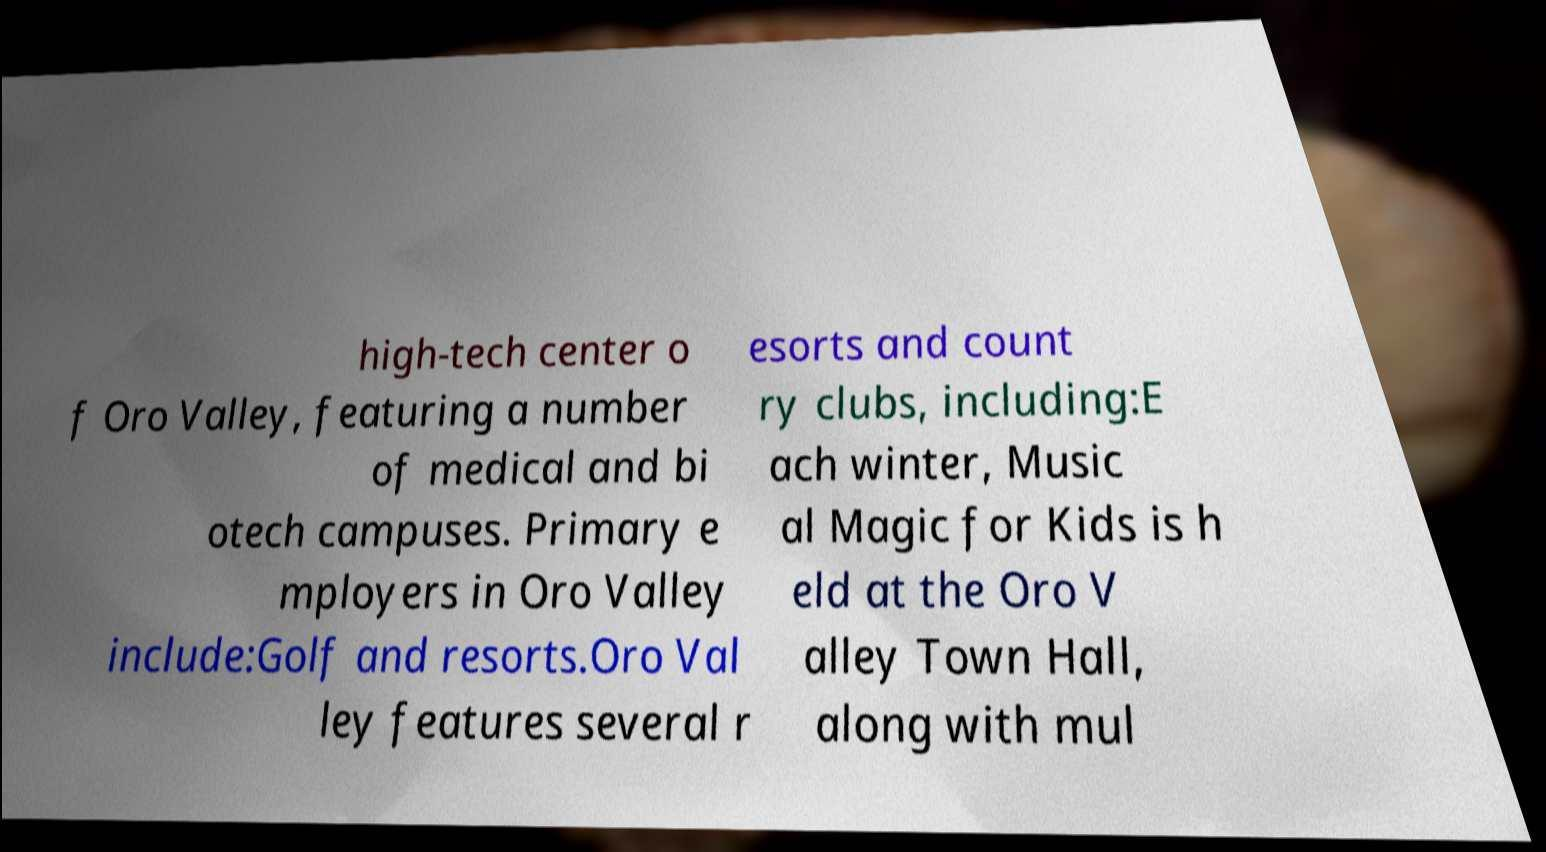Could you assist in decoding the text presented in this image and type it out clearly? high-tech center o f Oro Valley, featuring a number of medical and bi otech campuses. Primary e mployers in Oro Valley include:Golf and resorts.Oro Val ley features several r esorts and count ry clubs, including:E ach winter, Music al Magic for Kids is h eld at the Oro V alley Town Hall, along with mul 